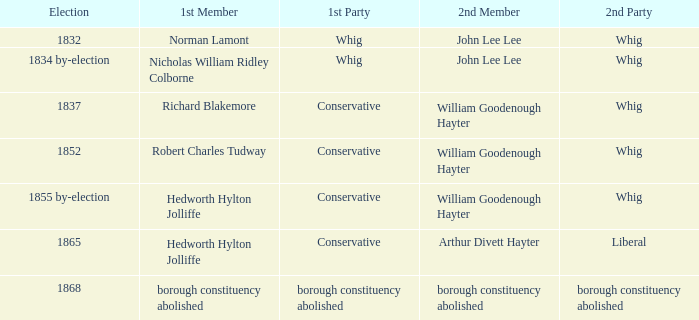What election has a 1st member of richard blakemore and a 2nd member of william goodenough hayter? 1837.0. 